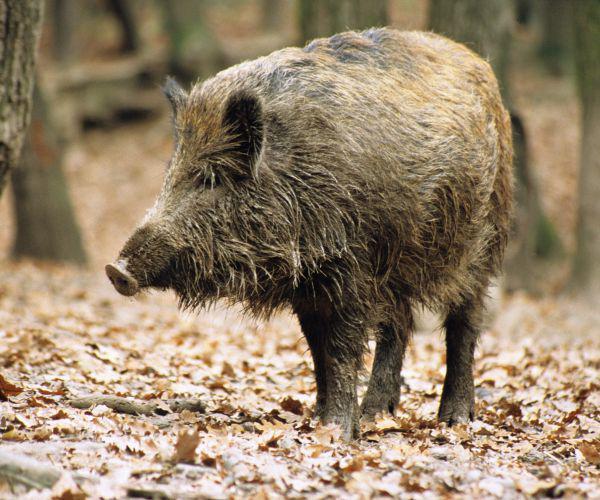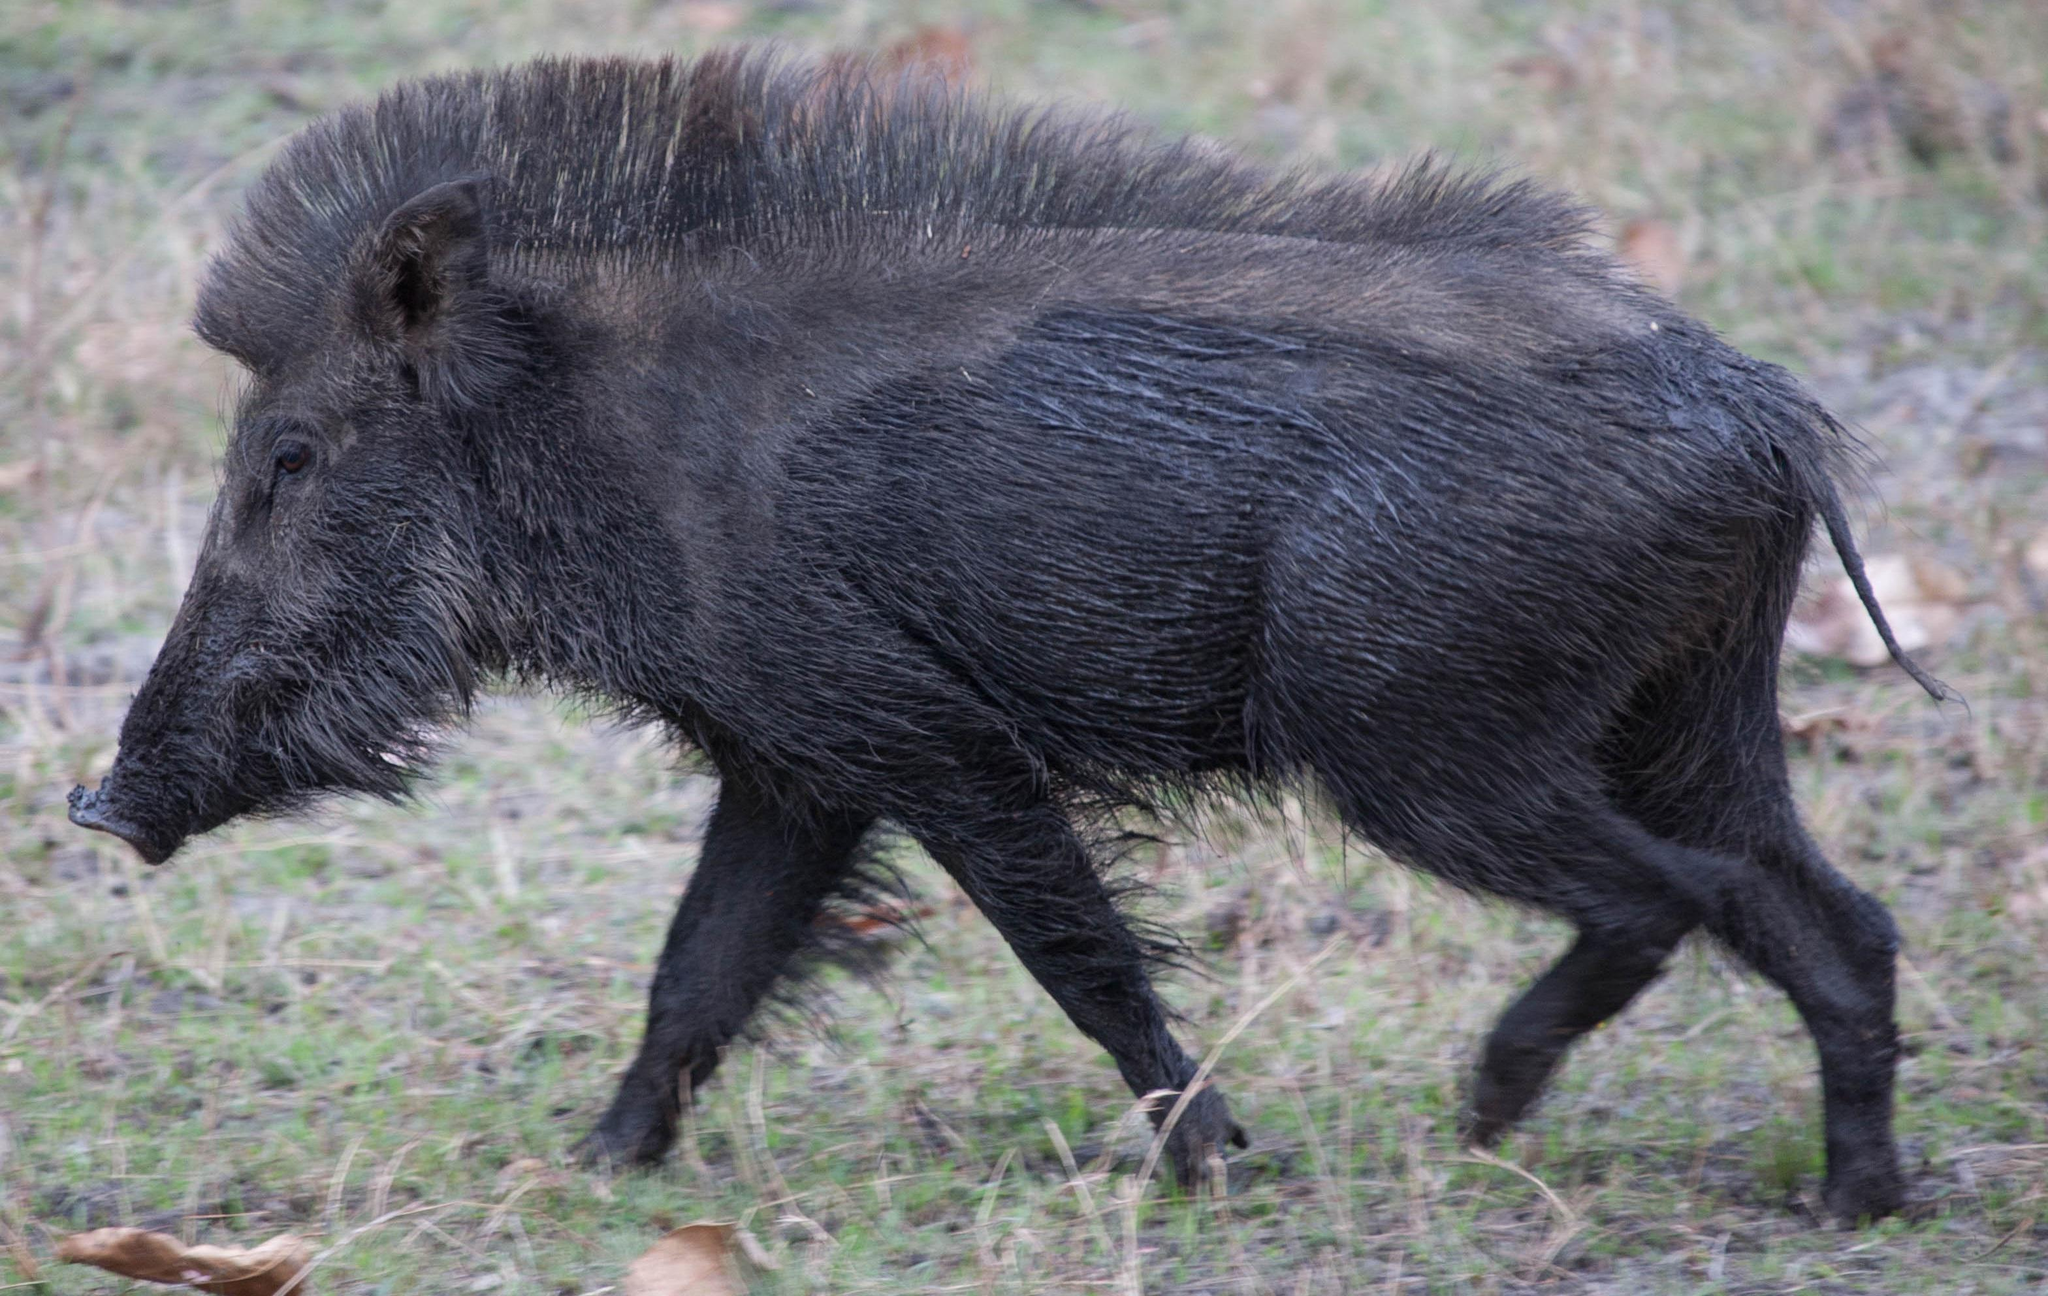The first image is the image on the left, the second image is the image on the right. For the images shown, is this caption "There are at most 3 hogs total." true? Answer yes or no. Yes. The first image is the image on the left, the second image is the image on the right. For the images shown, is this caption "An image shows one walking boar in full head and body profile." true? Answer yes or no. Yes. 